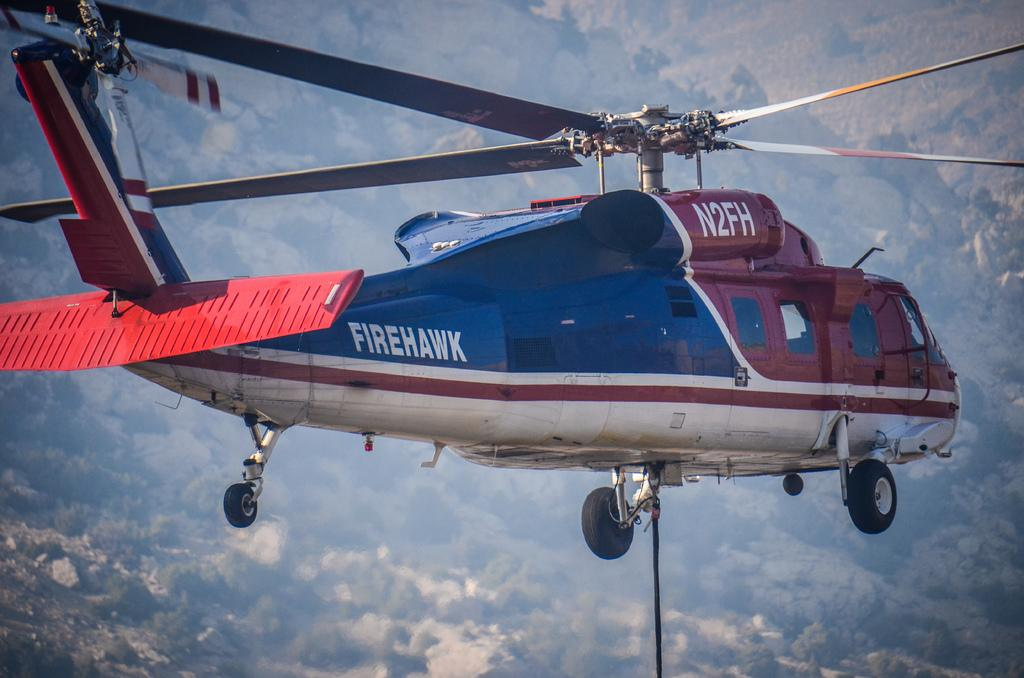<image>
Share a concise interpretation of the image provided. A firehawk helicopter labelled N2FH hovers in the air with a winch hanging from its underneath. 